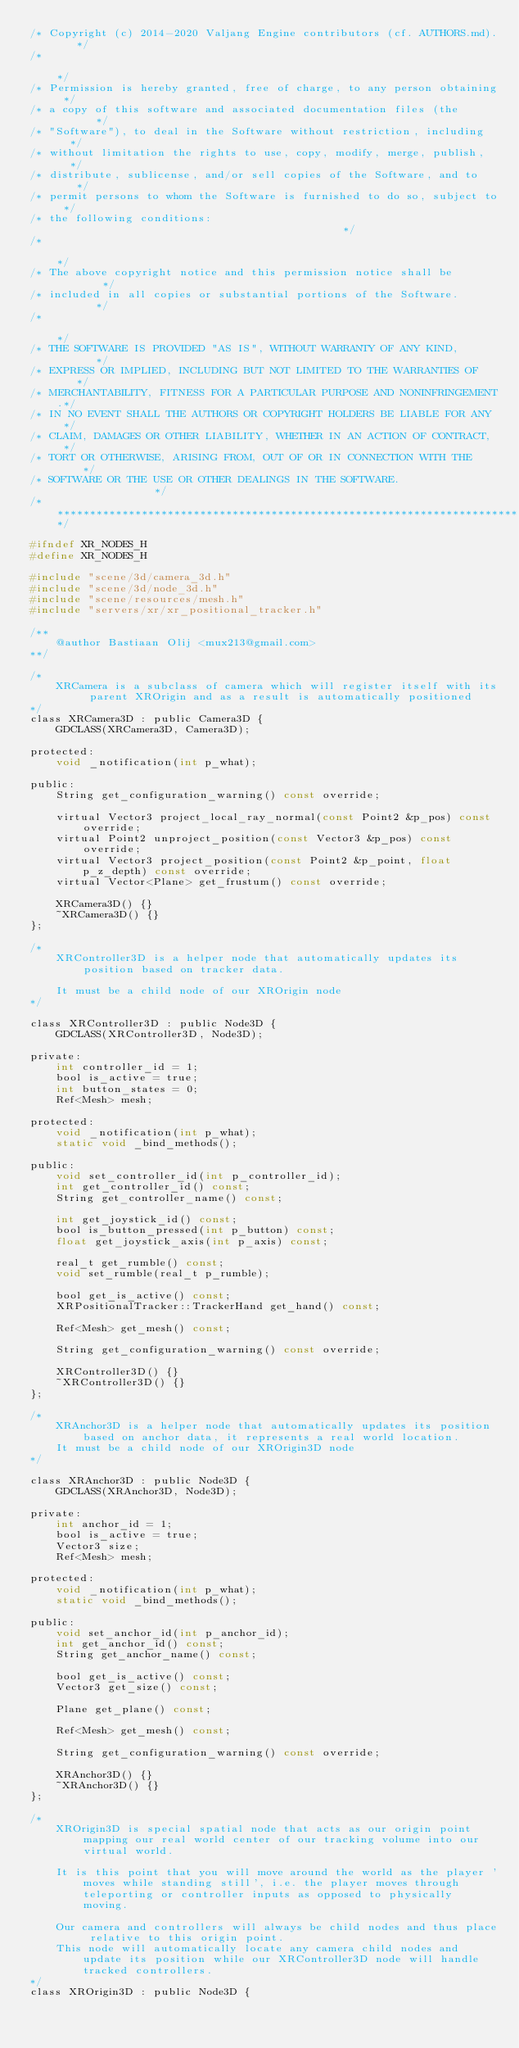Convert code to text. <code><loc_0><loc_0><loc_500><loc_500><_C_>/* Copyright (c) 2014-2020 Valjang Engine contributors (cf. AUTHORS.md).   */
/*                                                                       */
/* Permission is hereby granted, free of charge, to any person obtaining */
/* a copy of this software and associated documentation files (the       */
/* "Software"), to deal in the Software without restriction, including   */
/* without limitation the rights to use, copy, modify, merge, publish,   */
/* distribute, sublicense, and/or sell copies of the Software, and to    */
/* permit persons to whom the Software is furnished to do so, subject to */
/* the following conditions:                                             */
/*                                                                       */
/* The above copyright notice and this permission notice shall be        */
/* included in all copies or substantial portions of the Software.       */
/*                                                                       */
/* THE SOFTWARE IS PROVIDED "AS IS", WITHOUT WARRANTY OF ANY KIND,       */
/* EXPRESS OR IMPLIED, INCLUDING BUT NOT LIMITED TO THE WARRANTIES OF    */
/* MERCHANTABILITY, FITNESS FOR A PARTICULAR PURPOSE AND NONINFRINGEMENT.*/
/* IN NO EVENT SHALL THE AUTHORS OR COPYRIGHT HOLDERS BE LIABLE FOR ANY  */
/* CLAIM, DAMAGES OR OTHER LIABILITY, WHETHER IN AN ACTION OF CONTRACT,  */
/* TORT OR OTHERWISE, ARISING FROM, OUT OF OR IN CONNECTION WITH THE     */
/* SOFTWARE OR THE USE OR OTHER DEALINGS IN THE SOFTWARE.                */
/*************************************************************************/

#ifndef XR_NODES_H
#define XR_NODES_H

#include "scene/3d/camera_3d.h"
#include "scene/3d/node_3d.h"
#include "scene/resources/mesh.h"
#include "servers/xr/xr_positional_tracker.h"

/**
	@author Bastiaan Olij <mux213@gmail.com>
**/

/*
	XRCamera is a subclass of camera which will register itself with its parent XROrigin and as a result is automatically positioned
*/
class XRCamera3D : public Camera3D {
	GDCLASS(XRCamera3D, Camera3D);

protected:
	void _notification(int p_what);

public:
	String get_configuration_warning() const override;

	virtual Vector3 project_local_ray_normal(const Point2 &p_pos) const override;
	virtual Point2 unproject_position(const Vector3 &p_pos) const override;
	virtual Vector3 project_position(const Point2 &p_point, float p_z_depth) const override;
	virtual Vector<Plane> get_frustum() const override;

	XRCamera3D() {}
	~XRCamera3D() {}
};

/*
	XRController3D is a helper node that automatically updates its position based on tracker data.

	It must be a child node of our XROrigin node
*/

class XRController3D : public Node3D {
	GDCLASS(XRController3D, Node3D);

private:
	int controller_id = 1;
	bool is_active = true;
	int button_states = 0;
	Ref<Mesh> mesh;

protected:
	void _notification(int p_what);
	static void _bind_methods();

public:
	void set_controller_id(int p_controller_id);
	int get_controller_id() const;
	String get_controller_name() const;

	int get_joystick_id() const;
	bool is_button_pressed(int p_button) const;
	float get_joystick_axis(int p_axis) const;

	real_t get_rumble() const;
	void set_rumble(real_t p_rumble);

	bool get_is_active() const;
	XRPositionalTracker::TrackerHand get_hand() const;

	Ref<Mesh> get_mesh() const;

	String get_configuration_warning() const override;

	XRController3D() {}
	~XRController3D() {}
};

/*
	XRAnchor3D is a helper node that automatically updates its position based on anchor data, it represents a real world location.
	It must be a child node of our XROrigin3D node
*/

class XRAnchor3D : public Node3D {
	GDCLASS(XRAnchor3D, Node3D);

private:
	int anchor_id = 1;
	bool is_active = true;
	Vector3 size;
	Ref<Mesh> mesh;

protected:
	void _notification(int p_what);
	static void _bind_methods();

public:
	void set_anchor_id(int p_anchor_id);
	int get_anchor_id() const;
	String get_anchor_name() const;

	bool get_is_active() const;
	Vector3 get_size() const;

	Plane get_plane() const;

	Ref<Mesh> get_mesh() const;

	String get_configuration_warning() const override;

	XRAnchor3D() {}
	~XRAnchor3D() {}
};

/*
	XROrigin3D is special spatial node that acts as our origin point mapping our real world center of our tracking volume into our virtual world.

	It is this point that you will move around the world as the player 'moves while standing still', i.e. the player moves through teleporting or controller inputs as opposed to physically moving.

	Our camera and controllers will always be child nodes and thus place relative to this origin point.
	This node will automatically locate any camera child nodes and update its position while our XRController3D node will handle tracked controllers.
*/
class XROrigin3D : public Node3D {</code> 